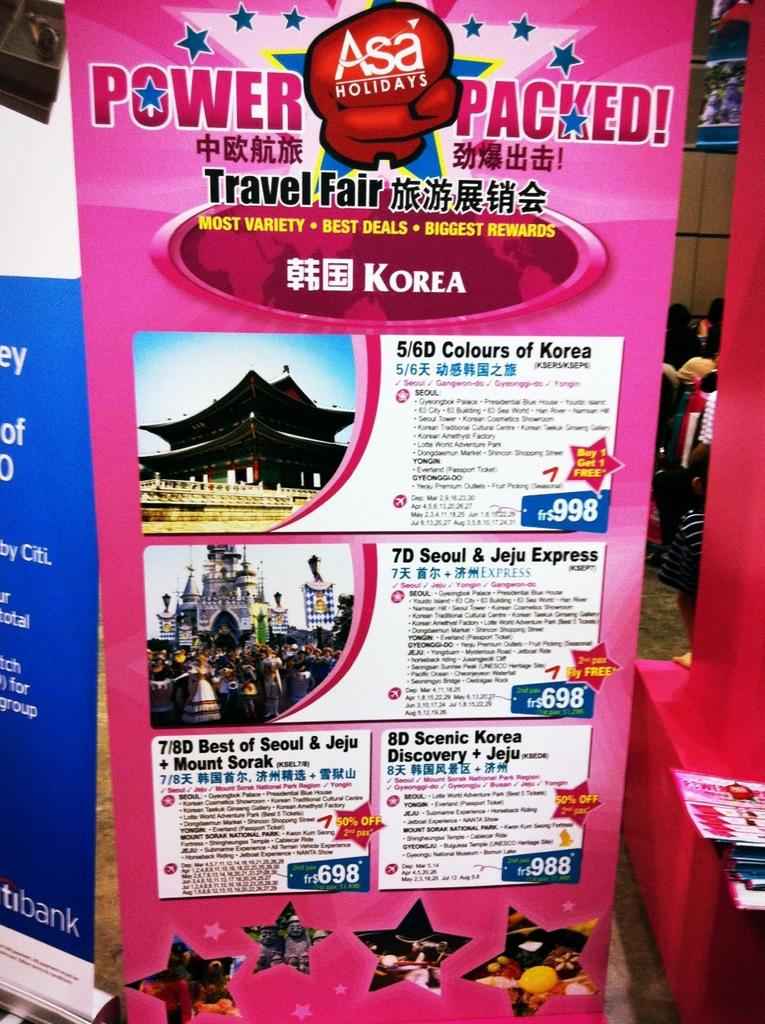<image>
Create a compact narrative representing the image presented. A poster shows the best deals for a power packed Korean holiday at a travel fair. 